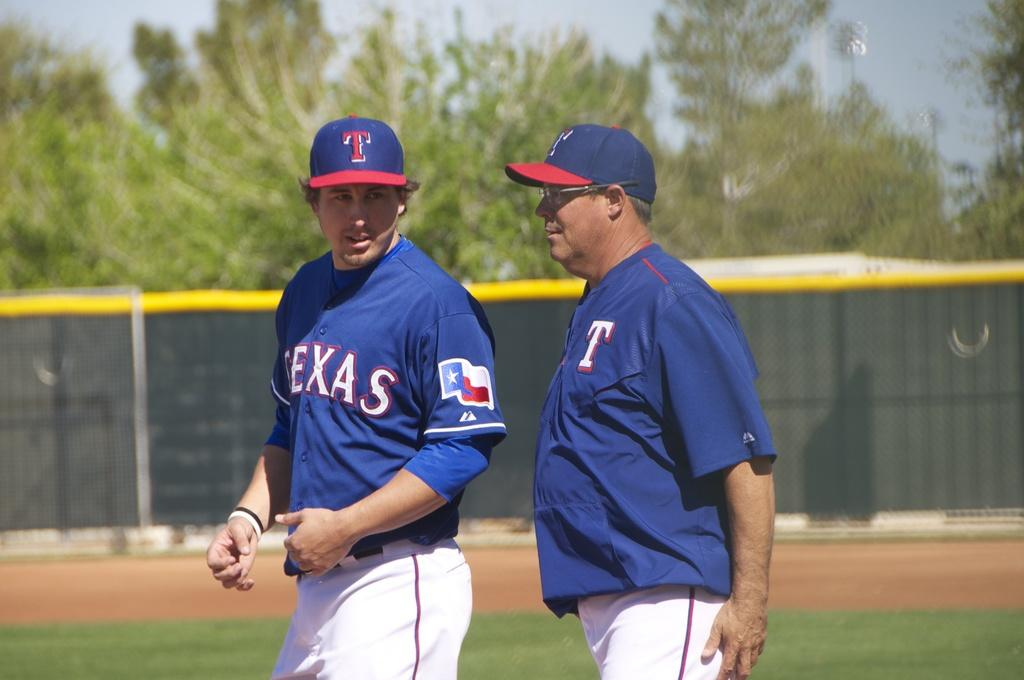<image>
Provide a brief description of the given image. The players on the baseball field are on a Texas team. 